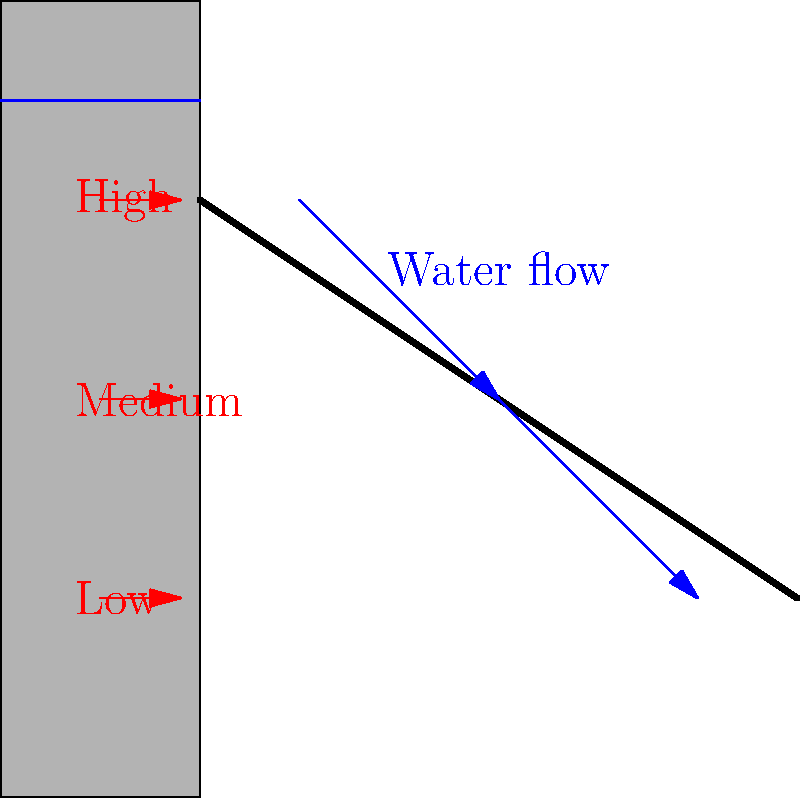As a Hollywood actor preparing for a role as a dam engineer, you need to understand the basics of water flow through a dam spillway. Based on the diagram, which shows water flowing over a dam spillway with arrows indicating direction and pressure, what can you conclude about the relationship between water depth and pressure on the dam wall? To understand the relationship between water depth and pressure on the dam wall, let's break it down step-by-step:

1. Observe the diagram: The left side represents the dam wall, and the right side shows the spillway where water flows over.

2. Water level: Notice that the water level is higher on the left side of the dam.

3. Pressure indicators: The red arrows on the left side of the dam wall indicate pressure at different depths.

4. Pressure distribution:
   - The longest arrow is at the bottom, labeled "High"
   - The middle arrow is shorter, labeled "Medium"
   - The shortest arrow is at the top, labeled "Low"

5. Hydrostatic pressure principle: In fluid mechanics, pressure in a static fluid increases linearly with depth. This is known as hydrostatic pressure.

6. Application to the dam: The pressure distribution shown in the diagram follows this principle. The pressure is highest at the bottom of the dam where the water is deepest, and lowest at the top where the water is shallowest.

7. Mathematical representation: The hydrostatic pressure can be calculated using the formula:

   $$P = \rho g h$$

   Where:
   $P$ = pressure
   $\rho$ (rho) = density of water
   $g$ = acceleration due to gravity
   $h$ = depth of water

8. Conclusion: As the depth of water increases, the pressure on the dam wall also increases linearly.
Answer: As water depth increases, pressure on the dam wall increases linearly. 